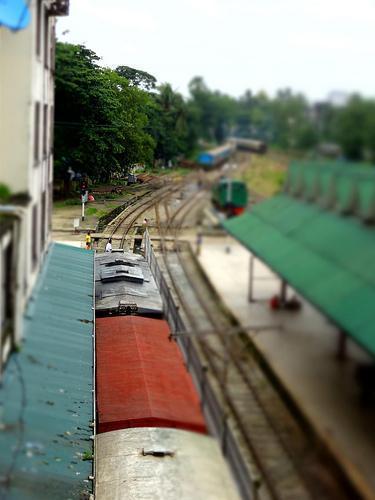How many train cars are in the front of the picture?
Give a very brief answer. 3. 